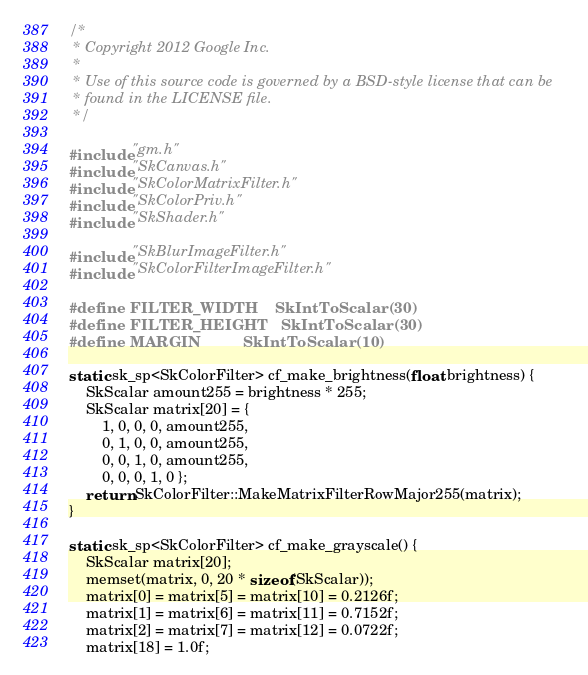<code> <loc_0><loc_0><loc_500><loc_500><_C++_>/*
 * Copyright 2012 Google Inc.
 *
 * Use of this source code is governed by a BSD-style license that can be
 * found in the LICENSE file.
 */

#include "gm.h"
#include "SkCanvas.h"
#include "SkColorMatrixFilter.h"
#include "SkColorPriv.h"
#include "SkShader.h"

#include "SkBlurImageFilter.h"
#include "SkColorFilterImageFilter.h"

#define FILTER_WIDTH    SkIntToScalar(30)
#define FILTER_HEIGHT   SkIntToScalar(30)
#define MARGIN          SkIntToScalar(10)

static sk_sp<SkColorFilter> cf_make_brightness(float brightness) {
    SkScalar amount255 = brightness * 255;
    SkScalar matrix[20] = {
        1, 0, 0, 0, amount255,
        0, 1, 0, 0, amount255,
        0, 0, 1, 0, amount255,
        0, 0, 0, 1, 0 };
    return SkColorFilter::MakeMatrixFilterRowMajor255(matrix);
}

static sk_sp<SkColorFilter> cf_make_grayscale() {
    SkScalar matrix[20];
    memset(matrix, 0, 20 * sizeof(SkScalar));
    matrix[0] = matrix[5] = matrix[10] = 0.2126f;
    matrix[1] = matrix[6] = matrix[11] = 0.7152f;
    matrix[2] = matrix[7] = matrix[12] = 0.0722f;
    matrix[18] = 1.0f;</code> 